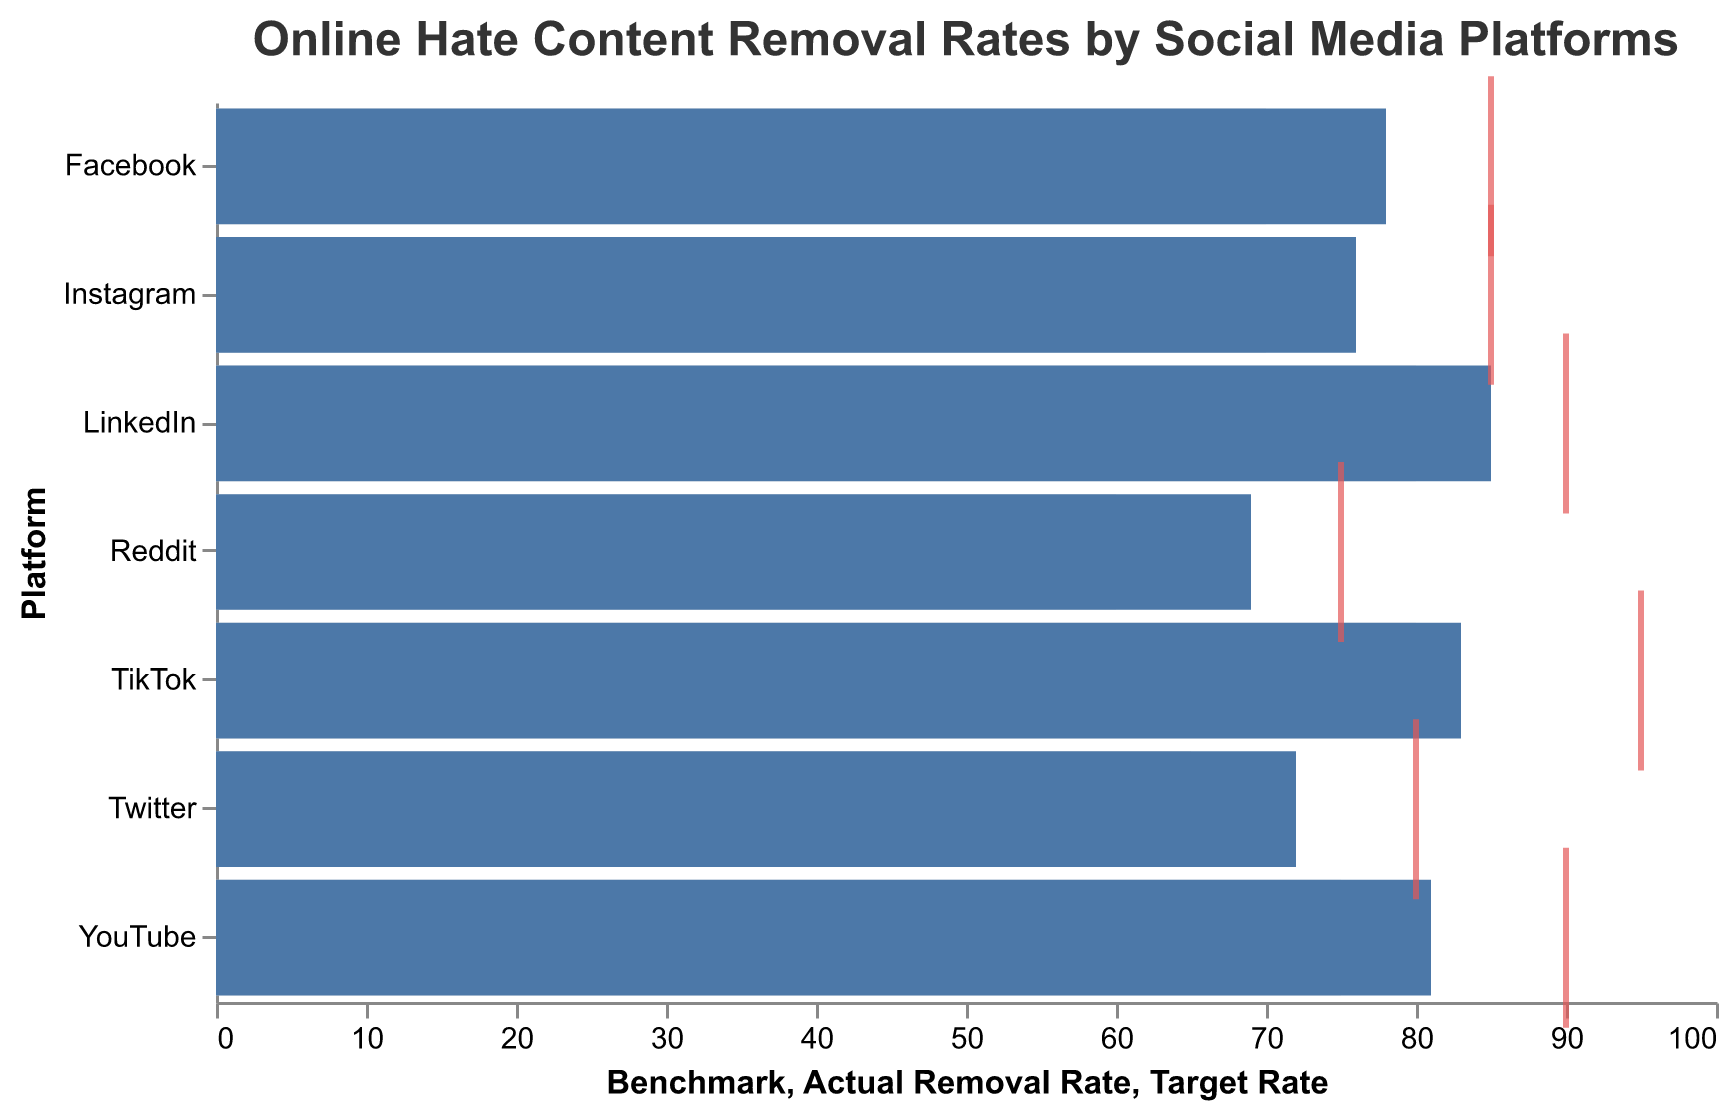What is the platform with the highest actual removal rate? The highest actual removal rate can be identified by looking at the bars of the "Actual Removal Rate" field. The tallest bar corresponds to LinkedIn.
Answer: LinkedIn What is the difference between the actual removal rate and the target rate for Facebook? To determine this, subtract the "Actual Removal Rate" for Facebook from its "Target Rate": 85 - 78 = 7
Answer: 7 Which social media platform has the lowest benchmark rate? The shortest bar in the "Benchmark" section indicates the lowest benchmark rate, which corresponds to Reddit.
Answer: Reddit How many platforms have an actual removal rate above 80? Count the platforms with bars extending beyond the 80 mark in the "Actual Removal Rate" field. There are three: YouTube, TikTok, and LinkedIn.
Answer: 3 What is the average target rate for all platforms? Add up all the "Target Rate" values, then divide by the number of platforms: (85 + 80 + 90 + 75 + 95 + 85 + 90) / 7 = 600 / 7 ≈ 85.71
Answer: 85.71 Which platform shows the greatest shortfall between the actual removal rate and the benchmark? Compute the difference between actual and benchmark rates for each platform and identify the greatest shortfall: Facebook (78-70=8), Twitter (72-65=7), YouTube (81-75=6), Reddit (69-60=9), TikTok (83-80=3), Instagram (76-70=6), LinkedIn (85-80=5). The greatest shortfall is for Reddit with 9.
Answer: Reddit Which social media platform exceeds its benchmark by the largest margin? Calculate the difference between the actual removal rate and the benchmark for each platform, and identify the largest margin: Facebook (78-70=8), Twitter (72-65=7), YouTube (81-75=6), Reddit (69-60=9), TikTok (83-80=3), Instagram (76-70=6), LinkedIn (85-80=5). The largest margin is for Reddit with 9.
Answer: Reddit Comparing YouTube and TikTok, which platform is closer to reaching its target rate? Calculate the shortfall for each platform from their target rate: YouTube (90-81=9), TikTok (95-83=12). YouTube is closer to its target rate with a shortfall of 9 compared to TikTok's 12.
Answer: YouTube 